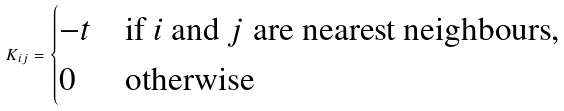Convert formula to latex. <formula><loc_0><loc_0><loc_500><loc_500>K _ { i j } = \begin{cases} - t & \text {if $i$ and $j$ are nearest neighbours} , \\ 0 & \text {otherwise} \end{cases}</formula> 